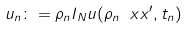Convert formula to latex. <formula><loc_0><loc_0><loc_500><loc_500>u _ { n } \colon = \rho _ { n } I _ { N } u ( \rho _ { n } \ x x ^ { \prime } , t _ { n } )</formula> 